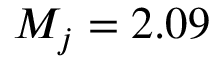<formula> <loc_0><loc_0><loc_500><loc_500>M _ { j } = 2 . 0 9</formula> 